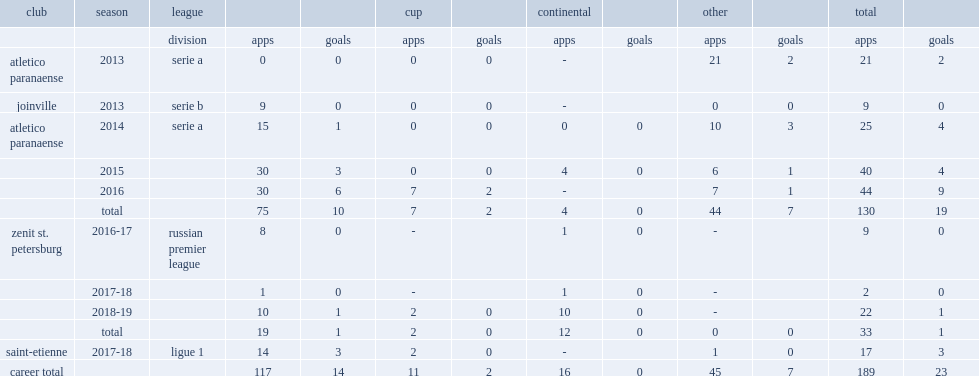Which club did hernani play for in 2013? Joinville. 